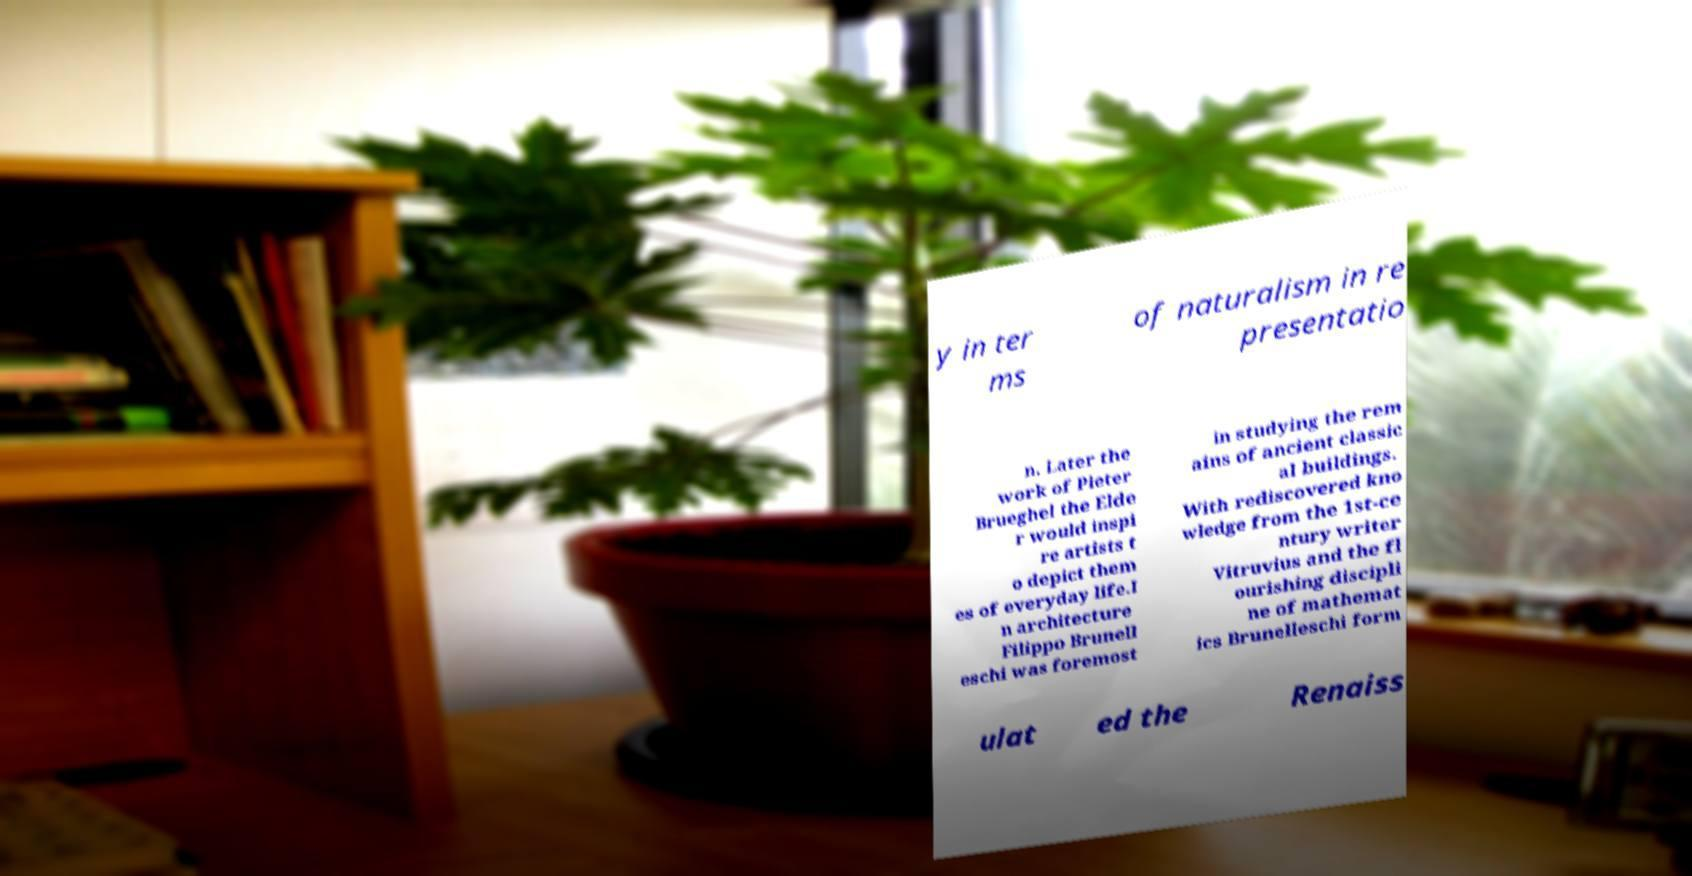Can you accurately transcribe the text from the provided image for me? y in ter ms of naturalism in re presentatio n. Later the work of Pieter Brueghel the Elde r would inspi re artists t o depict them es of everyday life.I n architecture Filippo Brunell eschi was foremost in studying the rem ains of ancient classic al buildings. With rediscovered kno wledge from the 1st-ce ntury writer Vitruvius and the fl ourishing discipli ne of mathemat ics Brunelleschi form ulat ed the Renaiss 